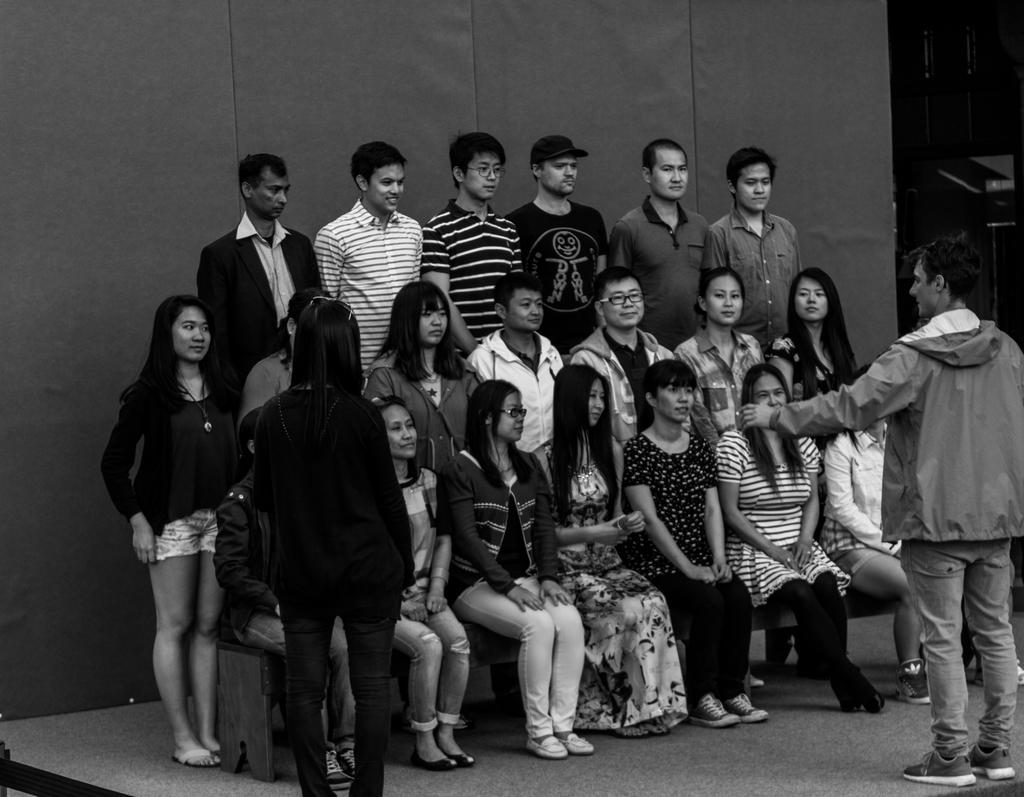What is the color scheme of the image? The image is black and white. What can be seen in the image? There are people in the image. What are some of the people in the image doing? Some people are sitting. What is visible at the bottom of the image? There is a floor visible at the bottom of the image. What type of scent can be detected in the image? There is no mention of any scent in the image, as it is a black and white image of people and a floor. 